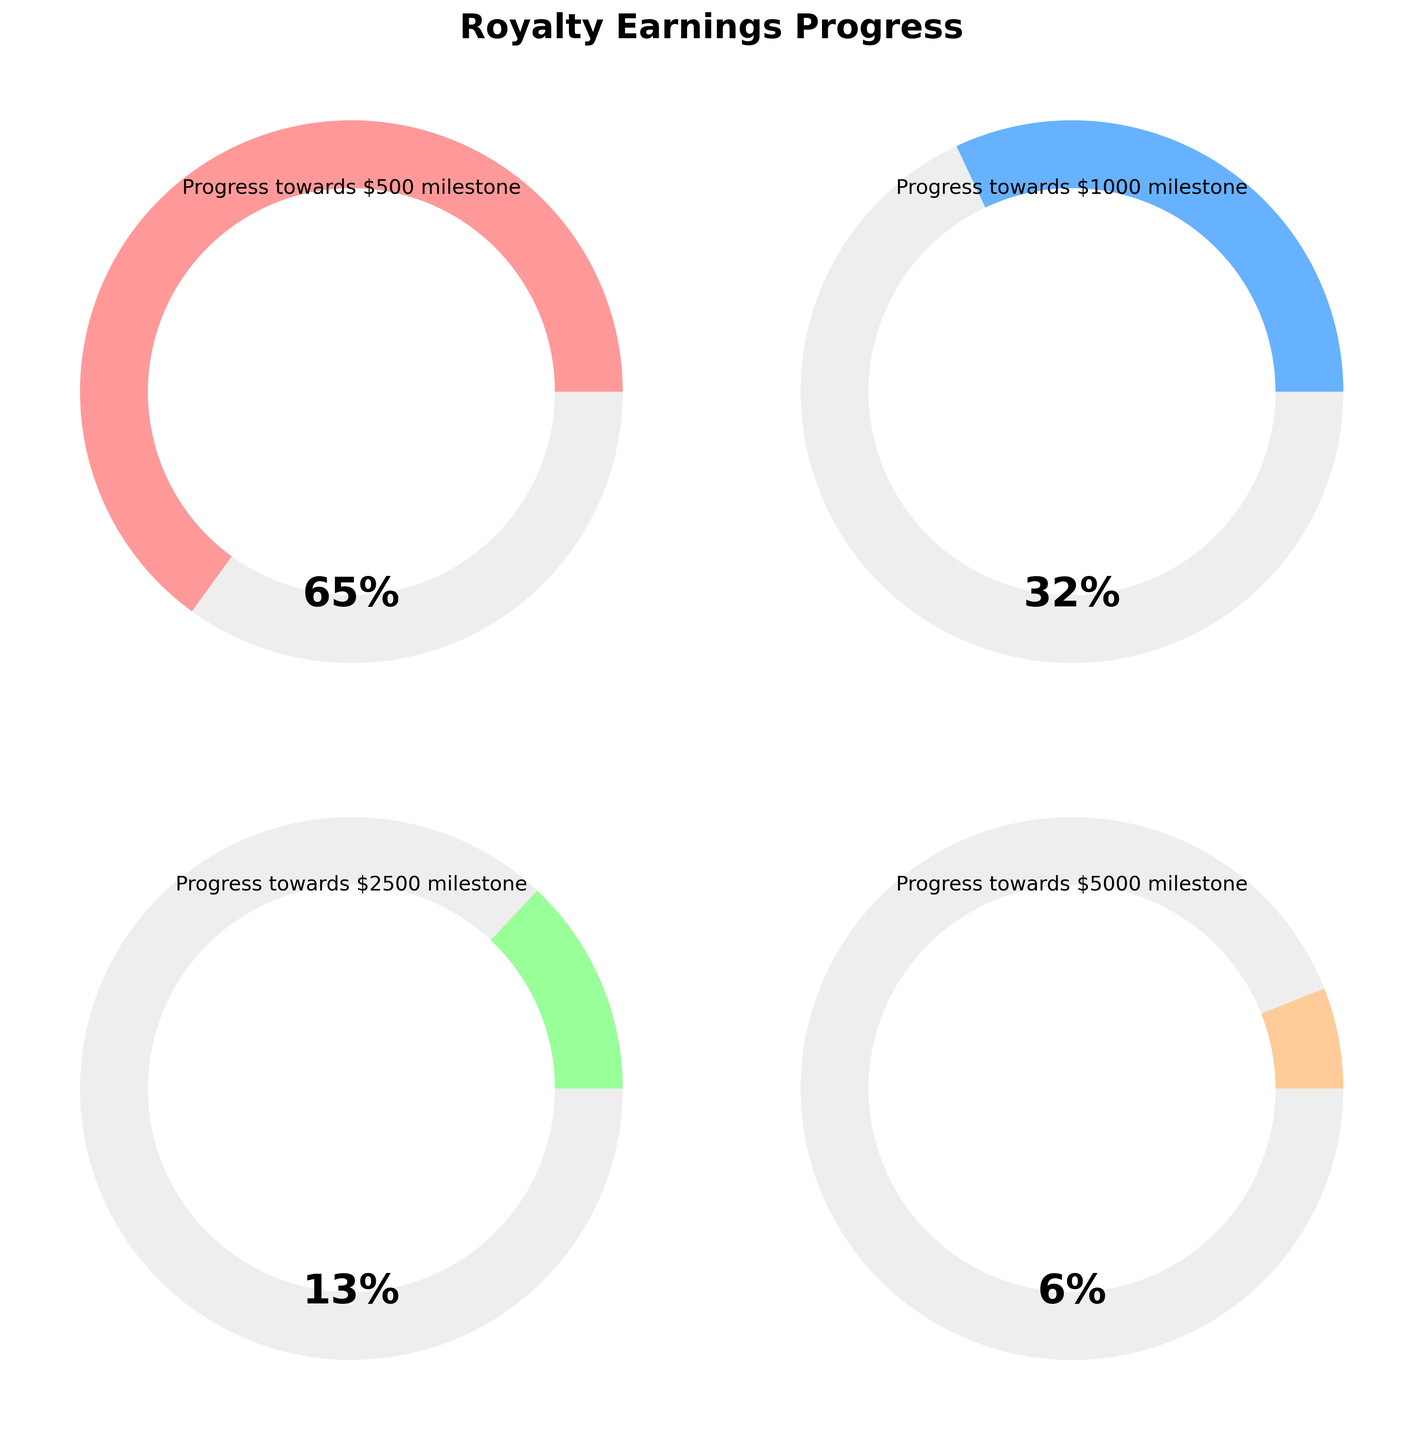What is the highest royalty milestone displayed in the figure? The highest milestone displayed is $5000, as indicated by the label "Progress towards $5000 milestone."
Answer: $5000 Which milestone has the greatest percentage progress? The milestone with the greatest percentage progress is "Progress towards $500 milestone" which has 65% completed.
Answer: $500 milestone What is the percentage progress towards the $1000 milestone? The percentage progress towards the $1000 milestone is displayed in the gauge chart with "Progress towards $1000 milestone", which shows 32%.
Answer: 32% How does the progress towards the $2500 milestone compare to the $500 milestone? The progress towards the $2500 milestone is 13%, while the progress towards the $500 milestone is 65%. Therefore, the $500 milestone has significantly higher progress.
Answer: The $500 milestone has higher progress What is the combined progress percentage if you sum the progress towards the $1000 and $2500 milestones? The progress towards the $1000 milestone is 32%, and the progress towards the $2500 milestone is 13%. Summing these gives 32% + 13% = 45%.
Answer: 45% Which milestone has the least percentage progress? The milestone with the least percentage progress is "Progress towards $5000 milestone," showing 6% progress.
Answer: $5000 milestone What color is used to represent the progress towards the $1000 milestone? The color used to represent the progress towards the $1000 milestone is a shade of blue, as indicated by its position in the gauge chart.
Answer: Blue How many milestones are displayed in the figure? There are four milestones displayed in the figure, each representing different earnings milestones.
Answer: Four Calculate the average percentage progress across all milestones. The percentage progresses are 65% (towards $500), 32% (towards $1000), 13% (towards $2500), and 6% (towards $5000). The average percentage progress is calculated as: (65 + 32 + 13 + 6) / 4 = 116 / 4 = 29%.
Answer: 29% Which two milestones together make up more than half of the progress towards their milestones when combined? The milestones towards the $500 (65%) and $1000 (32%) milestones together make up 65% + 32% = 97%, which is more than half or 50% of their progress combined.
Answer: $500 and $1000 milestones 